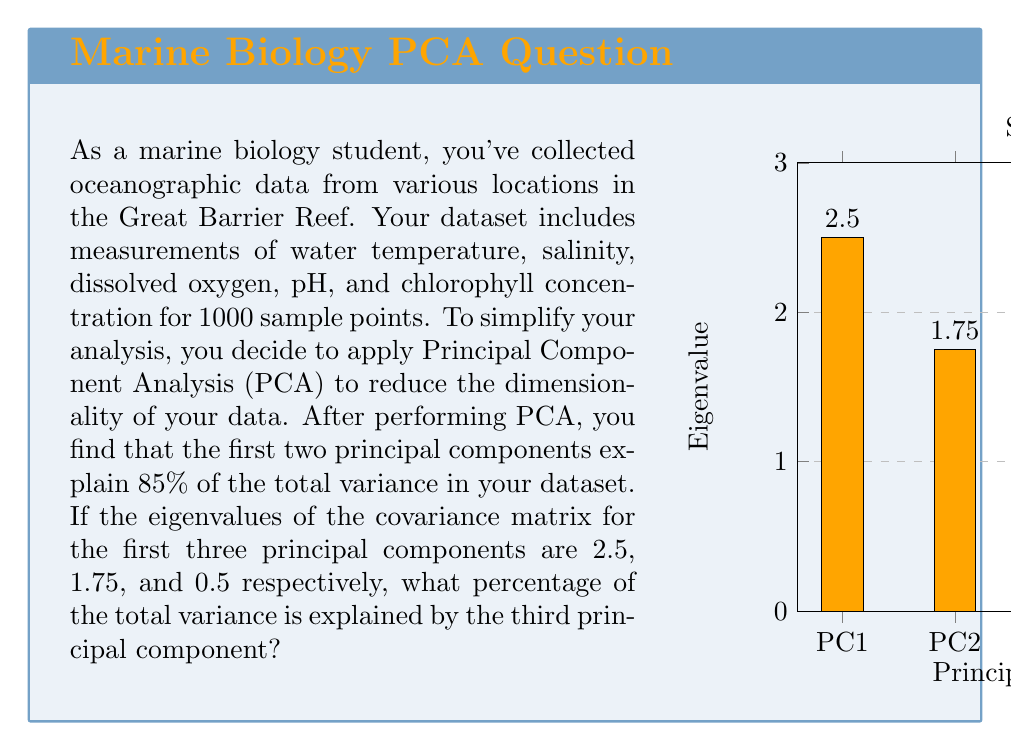Teach me how to tackle this problem. To solve this problem, we'll follow these steps:

1) First, recall that in PCA, the proportion of variance explained by each principal component is equal to its eigenvalue divided by the sum of all eigenvalues.

2) We're given the eigenvalues for the first three principal components:
   $\lambda_1 = 2.5$, $\lambda_2 = 1.75$, $\lambda_3 = 0.5$

3) We're also told that the first two principal components explain 85% of the total variance. Let's call the total variance $T$. Then:

   $\frac{2.5 + 1.75}{T} = 0.85$

4) We can use this to find $T$:

   $T = \frac{2.5 + 1.75}{0.85} = \frac{4.25}{0.85} = 5$

5) Now that we know the total variance, we can calculate the proportion of variance explained by the third principal component:

   $\text{Proportion} = \frac{\lambda_3}{T} = \frac{0.5}{5} = 0.1$

6) To express this as a percentage, we multiply by 100:

   $0.1 \times 100 = 10\%$

Therefore, the third principal component explains 10% of the total variance in the dataset.
Answer: 10% 